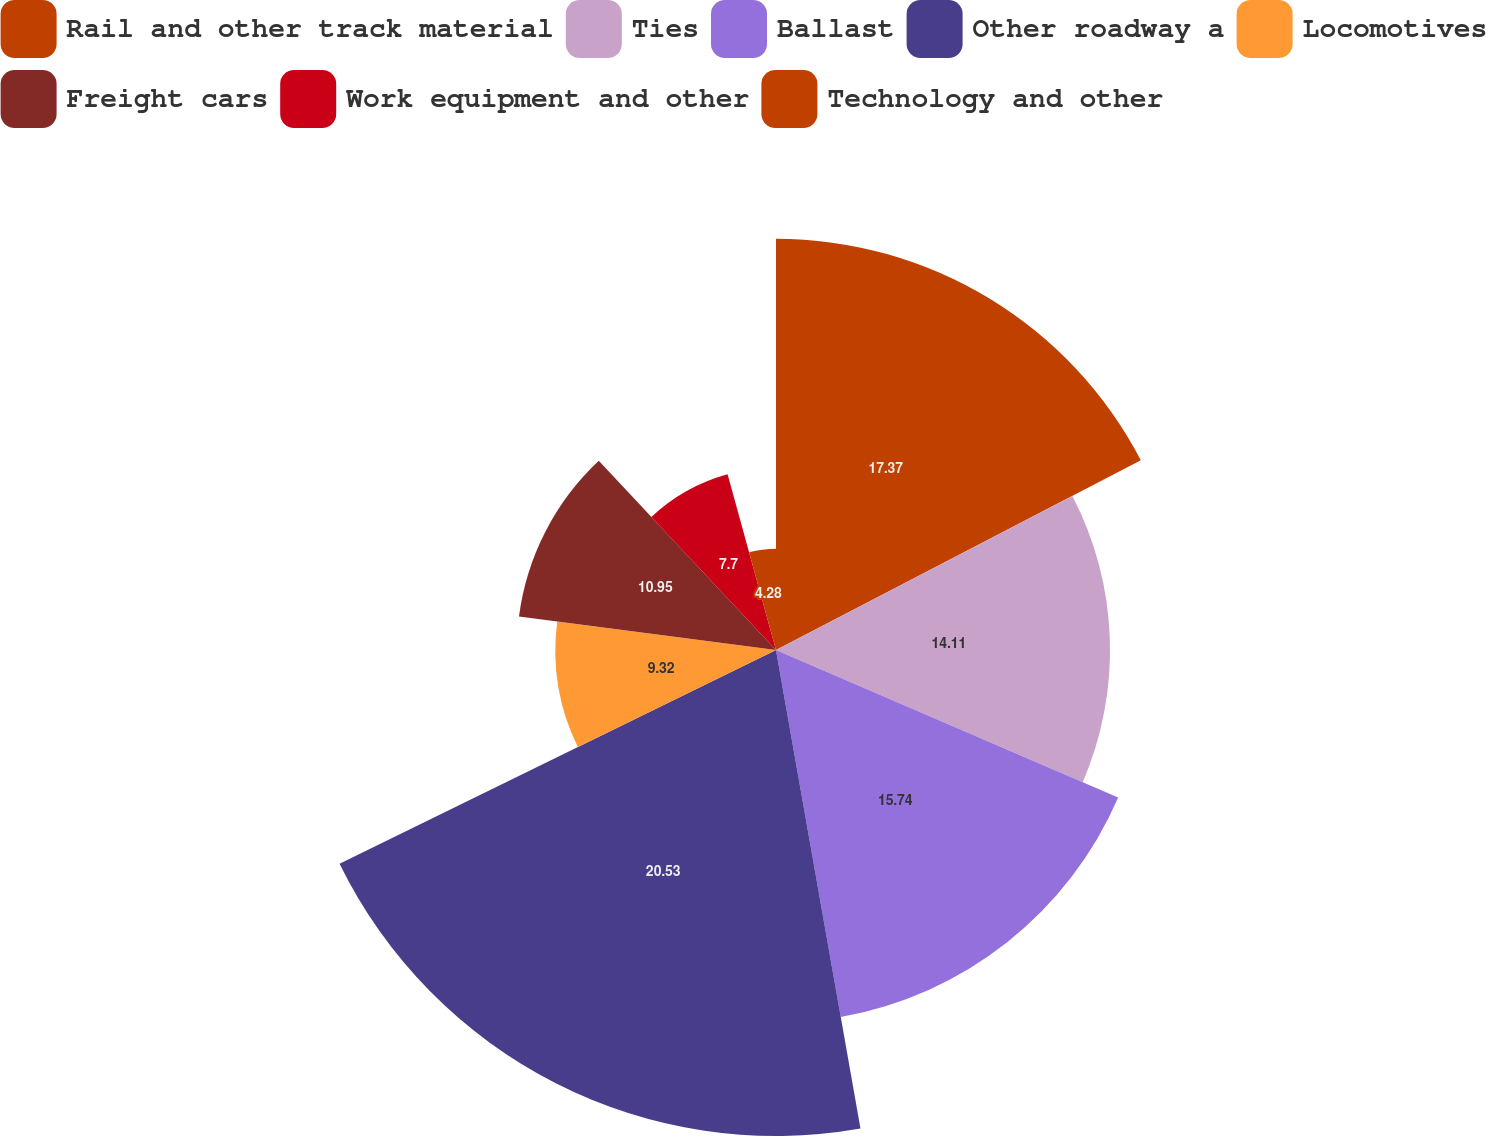Convert chart to OTSL. <chart><loc_0><loc_0><loc_500><loc_500><pie_chart><fcel>Rail and other track material<fcel>Ties<fcel>Ballast<fcel>Other roadway a<fcel>Locomotives<fcel>Freight cars<fcel>Work equipment and other<fcel>Technology and other<nl><fcel>17.37%<fcel>14.11%<fcel>15.74%<fcel>20.53%<fcel>9.32%<fcel>10.95%<fcel>7.7%<fcel>4.28%<nl></chart> 